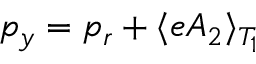<formula> <loc_0><loc_0><loc_500><loc_500>p _ { y } = p _ { r } + \langle e A _ { 2 } \rangle _ { T _ { 1 } }</formula> 